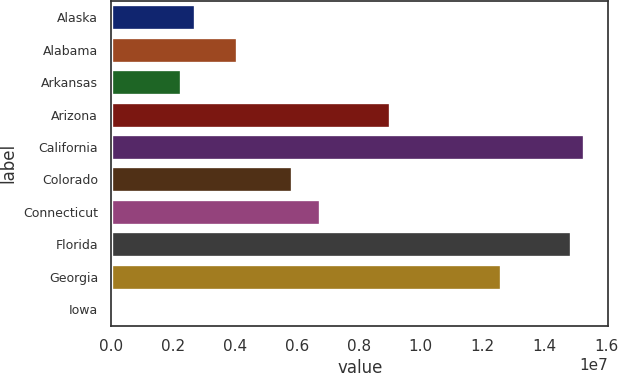Convert chart to OTSL. <chart><loc_0><loc_0><loc_500><loc_500><bar_chart><fcel>Alaska<fcel>Alabama<fcel>Arkansas<fcel>Arizona<fcel>California<fcel>Colorado<fcel>Connecticut<fcel>Florida<fcel>Georgia<fcel>Iowa<nl><fcel>2.70405e+06<fcel>4.05277e+06<fcel>2.25448e+06<fcel>8.99808e+06<fcel>1.52921e+07<fcel>5.85107e+06<fcel>6.75021e+06<fcel>1.48425e+07<fcel>1.25947e+07<fcel>6615<nl></chart> 